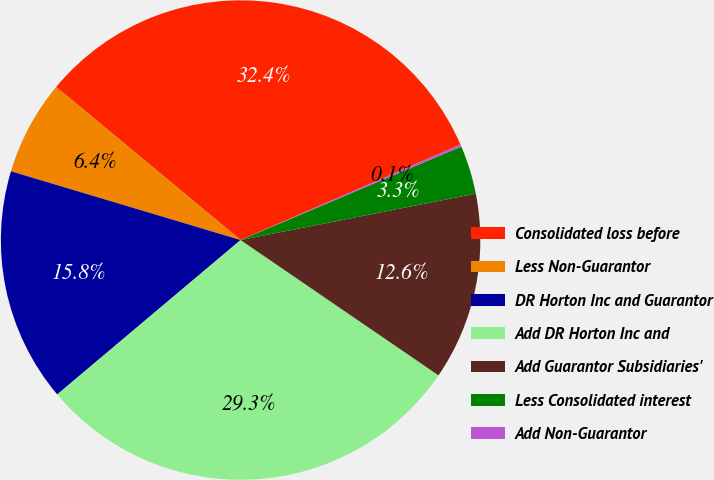Convert chart. <chart><loc_0><loc_0><loc_500><loc_500><pie_chart><fcel>Consolidated loss before<fcel>Less Non-Guarantor<fcel>DR Horton Inc and Guarantor<fcel>Add DR Horton Inc and<fcel>Add Guarantor Subsidiaries'<fcel>Less Consolidated interest<fcel>Add Non-Guarantor<nl><fcel>32.45%<fcel>6.4%<fcel>15.77%<fcel>29.32%<fcel>12.65%<fcel>3.27%<fcel>0.15%<nl></chart> 